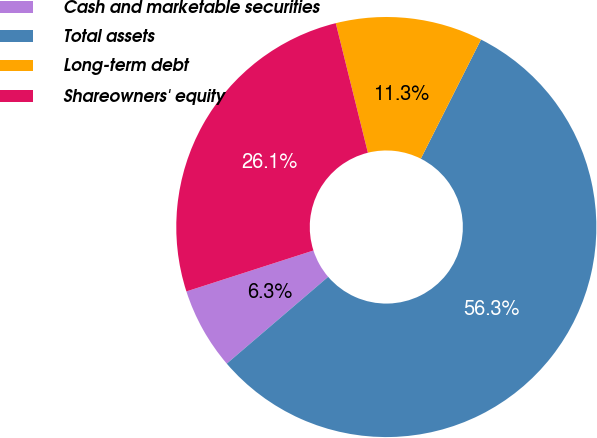<chart> <loc_0><loc_0><loc_500><loc_500><pie_chart><fcel>Cash and marketable securities<fcel>Total assets<fcel>Long-term debt<fcel>Shareowners' equity<nl><fcel>6.31%<fcel>56.28%<fcel>11.31%<fcel>26.09%<nl></chart> 